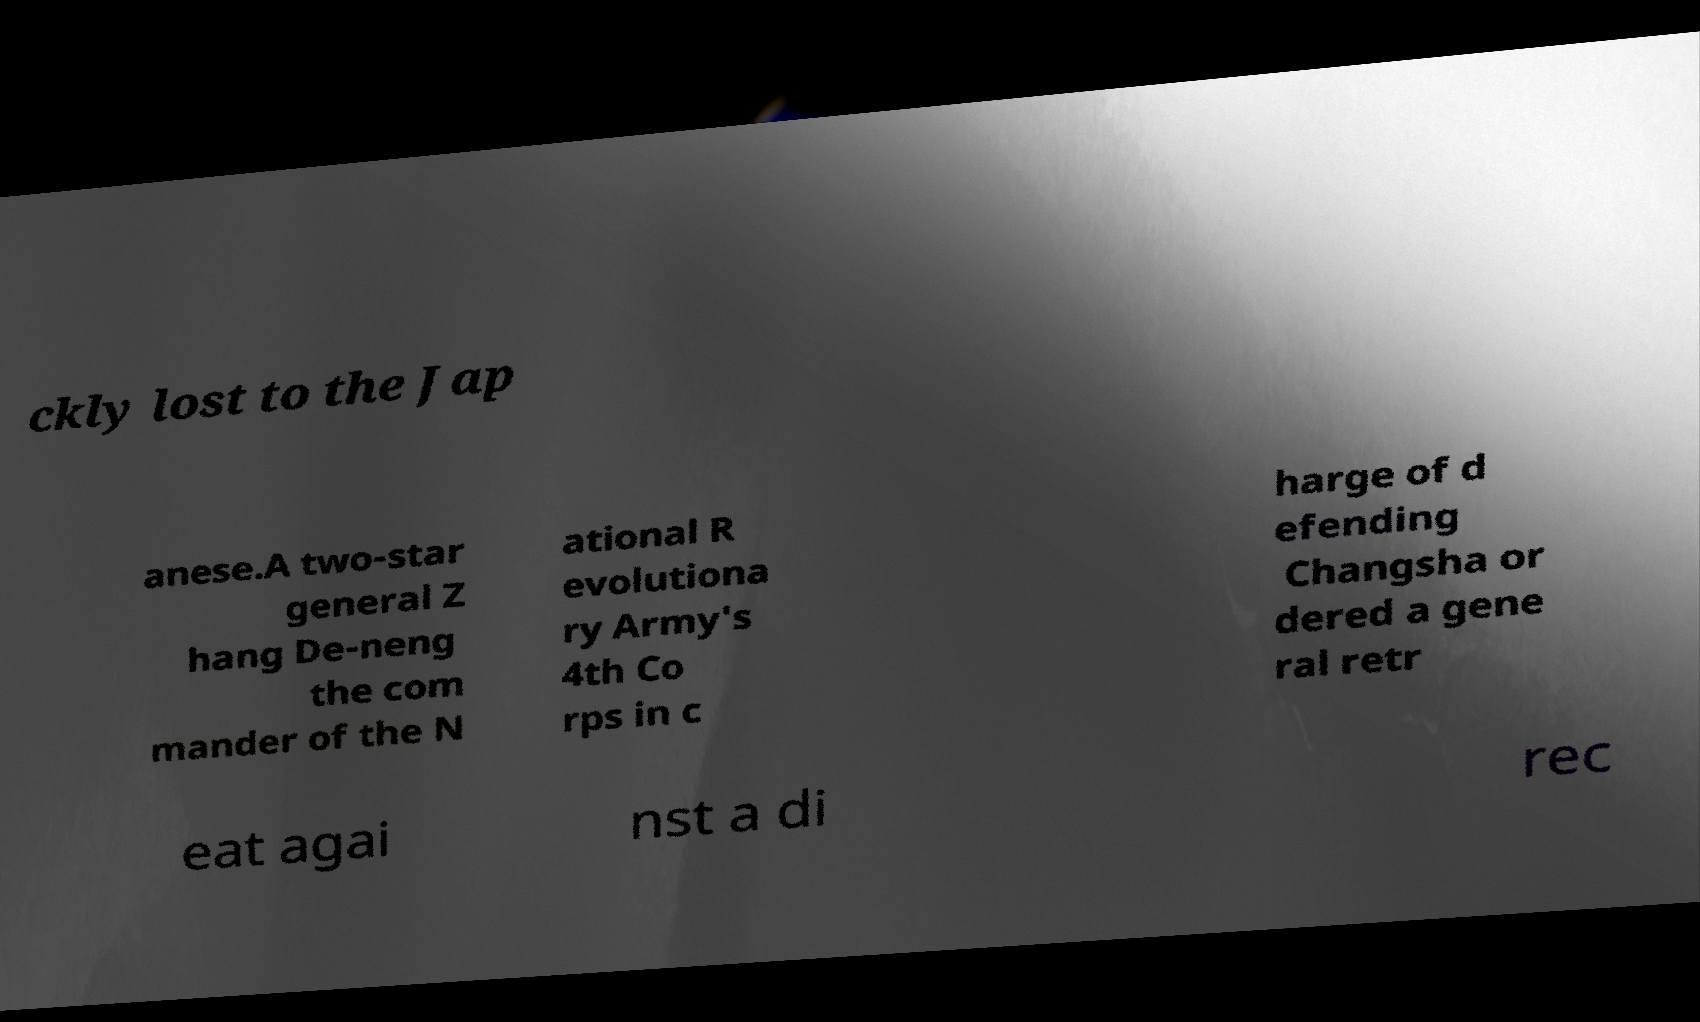There's text embedded in this image that I need extracted. Can you transcribe it verbatim? ckly lost to the Jap anese.A two-star general Z hang De-neng the com mander of the N ational R evolutiona ry Army's 4th Co rps in c harge of d efending Changsha or dered a gene ral retr eat agai nst a di rec 